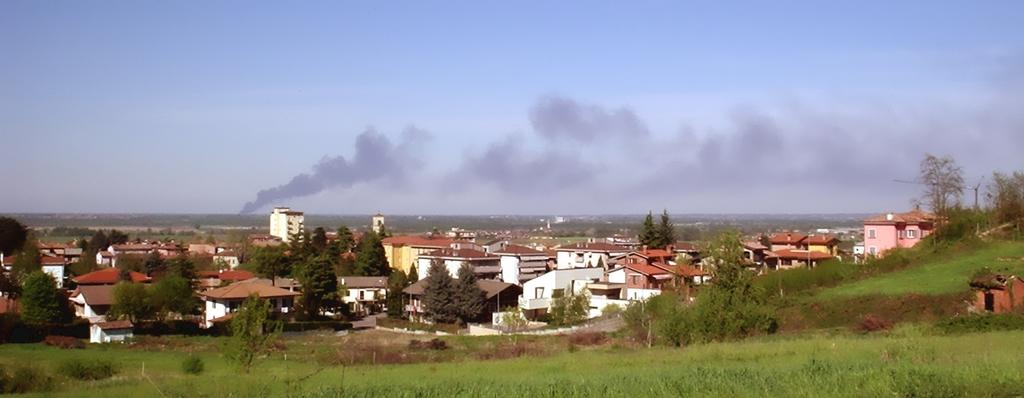What type of structures can be seen in the image? There are buildings in the image. What other natural elements are present in the image? There are trees, plants, and hills visible in the image. What man-made objects can be seen in the image? Street poles and street lights are present in the image. What is visible in the sky in the image? The sky is visible in the image, and clouds are present. Can you see a cushion on top of the hill in the image? There is no cushion present in the image. Is there a pig grazing in the field in the image? There is no pig present in the image. 